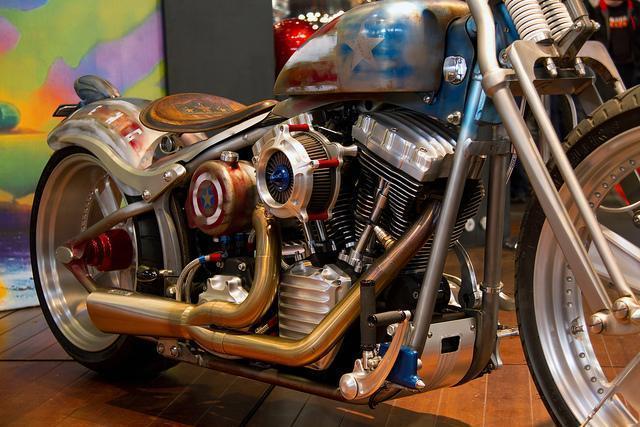How many wheels does this have?
Give a very brief answer. 2. How many bikes are in the photo?
Give a very brief answer. 1. How many motorcycles can be seen?
Give a very brief answer. 1. 